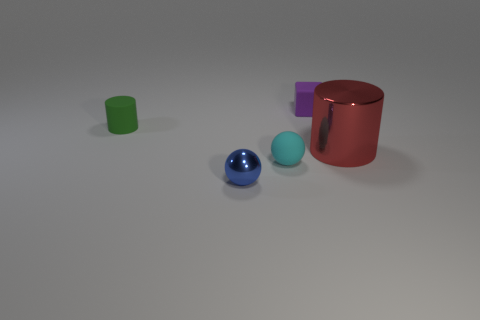Is there any other thing that has the same size as the red metal object?
Your answer should be very brief. No. What is the shape of the rubber thing on the left side of the tiny shiny sphere?
Provide a short and direct response. Cylinder. Are there fewer tiny cylinders than yellow metallic things?
Ensure brevity in your answer.  No. There is a shiny thing in front of the cylinder that is right of the small green thing; are there any rubber things that are in front of it?
Your answer should be compact. No. What number of metal objects are either small brown blocks or small purple blocks?
Make the answer very short. 0. Is the big shiny cylinder the same color as the tiny rubber block?
Provide a short and direct response. No. How many spheres are left of the cyan rubber sphere?
Give a very brief answer. 1. What number of cylinders are left of the small purple thing and in front of the small green matte cylinder?
Your answer should be very brief. 0. The green thing that is made of the same material as the tiny cyan object is what shape?
Your response must be concise. Cylinder. There is a rubber cylinder that is left of the tiny purple thing; does it have the same size as the matte object in front of the big red cylinder?
Give a very brief answer. Yes. 